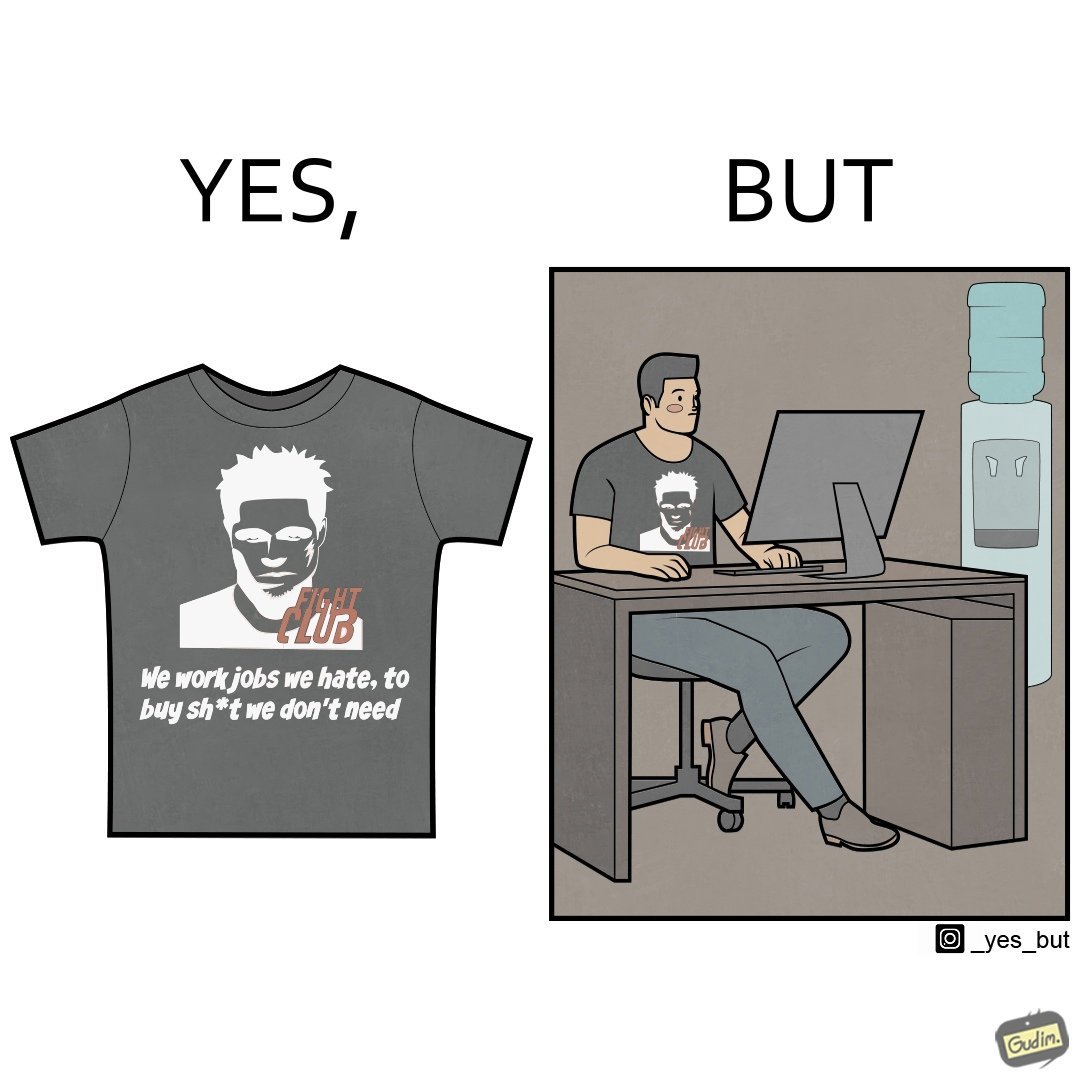Is this image satirical or non-satirical? Yes, this image is satirical. 